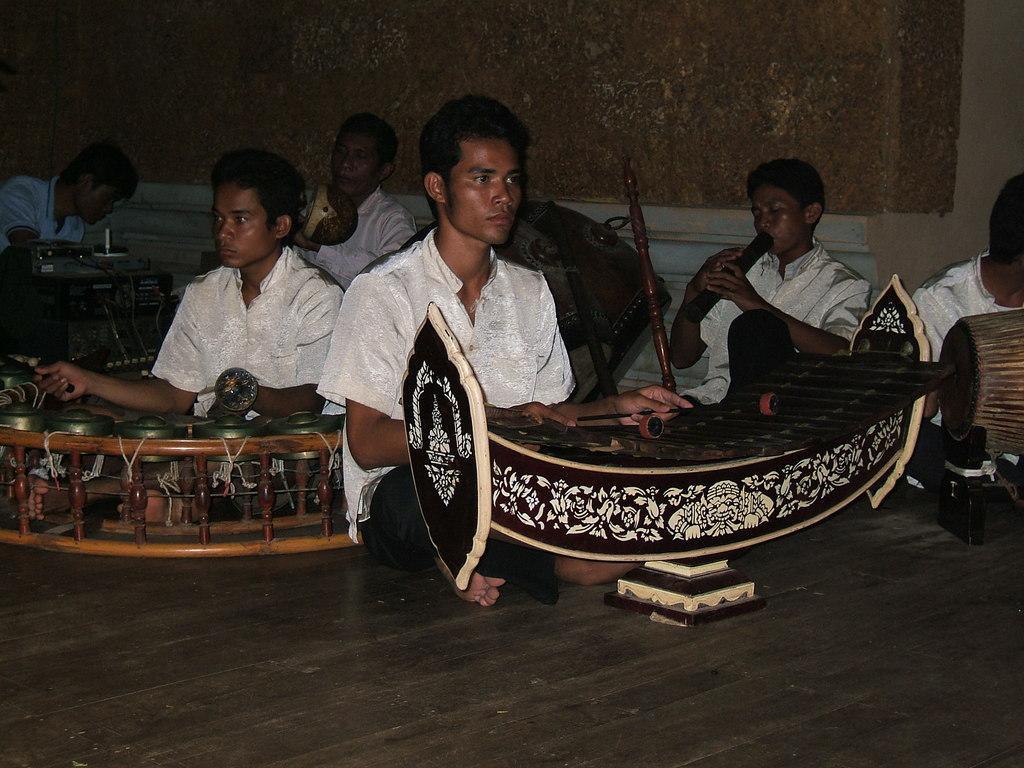How would you summarize this image in a sentence or two? In this picture there are group of people sitting and playing musical instruments. At the back there is a wall. At the bottom there is a floor. 